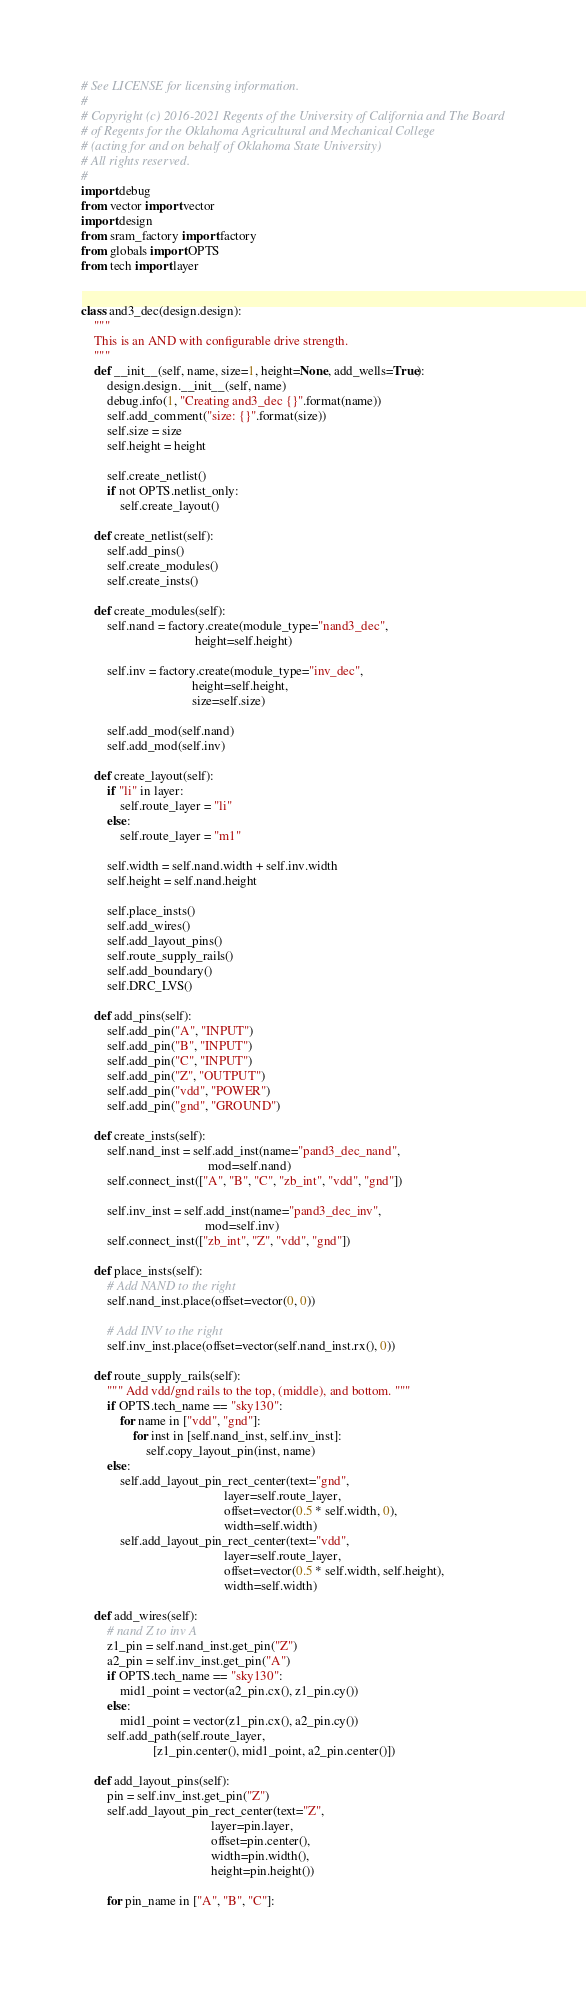<code> <loc_0><loc_0><loc_500><loc_500><_Python_># See LICENSE for licensing information.
#
# Copyright (c) 2016-2021 Regents of the University of California and The Board
# of Regents for the Oklahoma Agricultural and Mechanical College
# (acting for and on behalf of Oklahoma State University)
# All rights reserved.
#
import debug
from vector import vector
import design
from sram_factory import factory
from globals import OPTS
from tech import layer


class and3_dec(design.design):
    """
    This is an AND with configurable drive strength.
    """
    def __init__(self, name, size=1, height=None, add_wells=True):
        design.design.__init__(self, name)
        debug.info(1, "Creating and3_dec {}".format(name))
        self.add_comment("size: {}".format(size))
        self.size = size
        self.height = height

        self.create_netlist()
        if not OPTS.netlist_only:
            self.create_layout()

    def create_netlist(self):
        self.add_pins()
        self.create_modules()
        self.create_insts()

    def create_modules(self):
        self.nand = factory.create(module_type="nand3_dec",
                                   height=self.height)

        self.inv = factory.create(module_type="inv_dec",
                                  height=self.height,
                                  size=self.size)

        self.add_mod(self.nand)
        self.add_mod(self.inv)

    def create_layout(self):
        if "li" in layer:
            self.route_layer = "li"
        else:
            self.route_layer = "m1"

        self.width = self.nand.width + self.inv.width
        self.height = self.nand.height

        self.place_insts()
        self.add_wires()
        self.add_layout_pins()
        self.route_supply_rails()
        self.add_boundary()
        self.DRC_LVS()

    def add_pins(self):
        self.add_pin("A", "INPUT")
        self.add_pin("B", "INPUT")
        self.add_pin("C", "INPUT")
        self.add_pin("Z", "OUTPUT")
        self.add_pin("vdd", "POWER")
        self.add_pin("gnd", "GROUND")

    def create_insts(self):
        self.nand_inst = self.add_inst(name="pand3_dec_nand",
                                       mod=self.nand)
        self.connect_inst(["A", "B", "C", "zb_int", "vdd", "gnd"])

        self.inv_inst = self.add_inst(name="pand3_dec_inv",
                                      mod=self.inv)
        self.connect_inst(["zb_int", "Z", "vdd", "gnd"])

    def place_insts(self):
        # Add NAND to the right
        self.nand_inst.place(offset=vector(0, 0))

        # Add INV to the right
        self.inv_inst.place(offset=vector(self.nand_inst.rx(), 0))

    def route_supply_rails(self):
        """ Add vdd/gnd rails to the top, (middle), and bottom. """
        if OPTS.tech_name == "sky130":
            for name in ["vdd", "gnd"]:
                for inst in [self.nand_inst, self.inv_inst]:
                    self.copy_layout_pin(inst, name)
        else:
            self.add_layout_pin_rect_center(text="gnd",
                                            layer=self.route_layer,
                                            offset=vector(0.5 * self.width, 0),
                                            width=self.width)
            self.add_layout_pin_rect_center(text="vdd",
                                            layer=self.route_layer,
                                            offset=vector(0.5 * self.width, self.height),
                                            width=self.width)

    def add_wires(self):
        # nand Z to inv A
        z1_pin = self.nand_inst.get_pin("Z")
        a2_pin = self.inv_inst.get_pin("A")
        if OPTS.tech_name == "sky130":
            mid1_point = vector(a2_pin.cx(), z1_pin.cy())
        else:
            mid1_point = vector(z1_pin.cx(), a2_pin.cy())
        self.add_path(self.route_layer,
                      [z1_pin.center(), mid1_point, a2_pin.center()])

    def add_layout_pins(self):
        pin = self.inv_inst.get_pin("Z")
        self.add_layout_pin_rect_center(text="Z",
                                        layer=pin.layer,
                                        offset=pin.center(),
                                        width=pin.width(),
                                        height=pin.height())

        for pin_name in ["A", "B", "C"]:</code> 